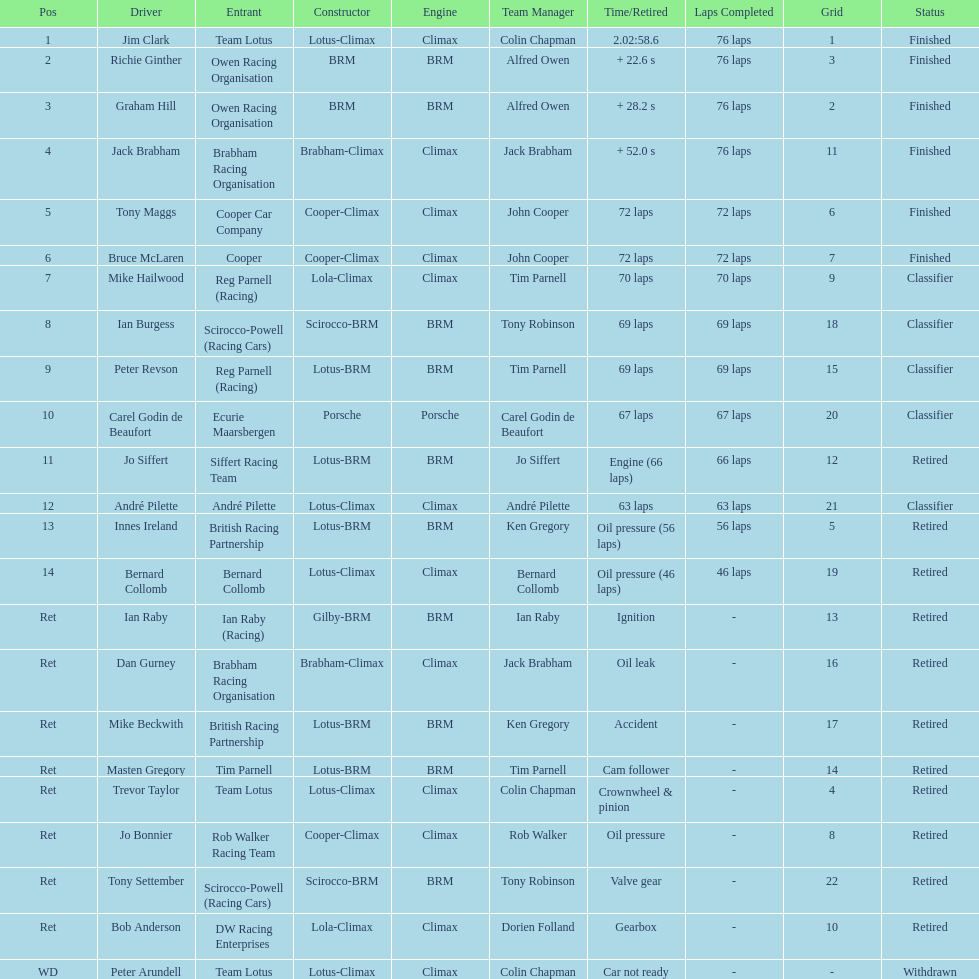What was the same problem that bernard collomb had as innes ireland? Oil pressure. 